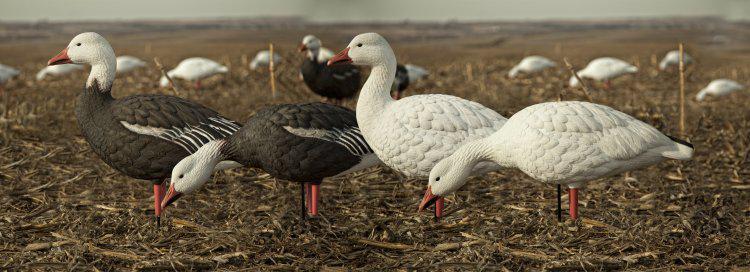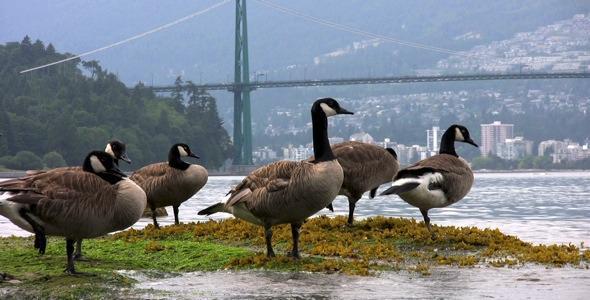The first image is the image on the left, the second image is the image on the right. Given the left and right images, does the statement "Each image shows a flock of canada geese with no fewer than 6 birds" hold true? Answer yes or no. No. The first image is the image on the left, the second image is the image on the right. For the images shown, is this caption "There are at least two ducks standing next to each other with orange beaks." true? Answer yes or no. Yes. 